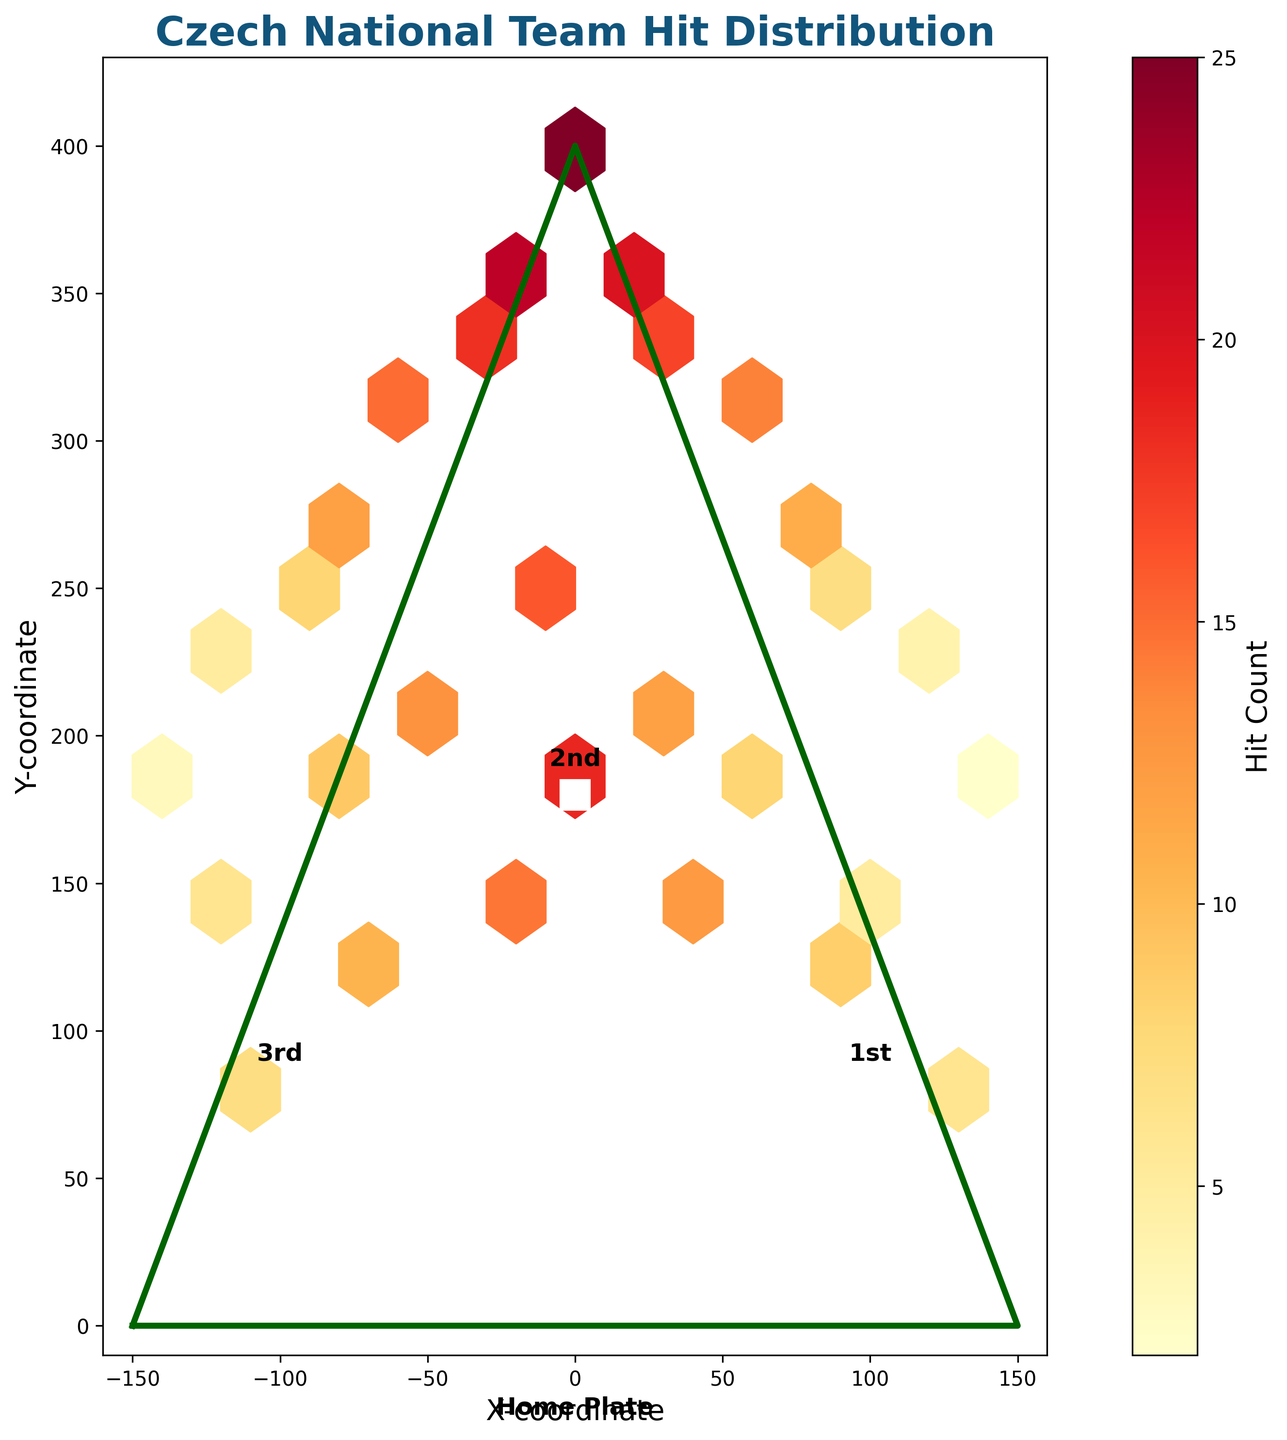What's the title of the figure? The title is displayed at the top of the plot. It summarizes the main subject of the chart, which is the hit distribution for the Czech National Team.
Answer: Czech National Team Hit Distribution What does the color represent in the hexbin plot? The color represents the hit count. Darker or more intense colors indicate a higher number of hits, while lighter colors indicate fewer hits.
Answer: Hit Count Where are the highest concentrations of hits located? To answer this, we look for the darkest and most intense hexagons on the plot. These appear around the center, particularly close to the (0, 400) coordinate.
Answer: Near (0, 400) What is the range of the x-coordinates on the plot? The x-axis ranges from negative to positive values. This is indicated by the axis labels that stretch from -160 to 160.
Answer: -160 to 160 At which base is the label "1st" located? By checking the labels on the figure, '1st' is located at the (90, 90) coordinate.
Answer: (90, 90) How many bases are included on the field plot? Bases on the plot are indicated by the rectangles. Counting these, we find there are four bases on the field.
Answer: Four Which coordinate has the highest hit count and what is that count? By looking at the darkest hexagon, we note that the highest hit count is around the central area of the plot. The exact coordinate and count can be found at (0, 400) with a hit count of 25.
Answer: (0, 400), 25 Is the hit distribution symmetric around the center? To determine symmetry, we compare the concentration of hexagons and their hit counts on both sides of the center line (x=0). The distribution appears largely symmetric with similar intensities and counts on both sides.
Answer: Yes On average, are there more hits between the coordinates (40, 340) to (80, 280) or between (-40, 340) to (-80, 280)? First, identify the counts in the specified ranges and then compare totals. For (40, 340) to (80, 280): (14 + 11) = 25. For (-40, 340) to (-80, 280): (18 + 12) = 30. The second range has a higher hit count.
Answer: (-40, 340) to (-80, 280) What color represents the lowest hit counts and where are these hits located? The lightest colors on the color bar correspond to the lowest hit counts. These are found at the outer edges of the field, particularly around coordinates like (140, 190) and (-140, 190).
Answer: Light colors, edges of the field 